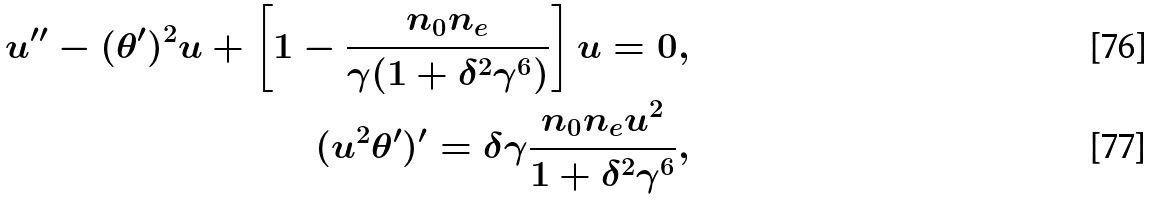Convert formula to latex. <formula><loc_0><loc_0><loc_500><loc_500>u ^ { \prime \prime } - ( \theta ^ { \prime } ) ^ { 2 } u + \left [ 1 - \frac { n _ { 0 } n _ { e } } { \gamma ( 1 + \delta ^ { 2 } \gamma ^ { 6 } ) } \right ] u = 0 , \\ ( u ^ { 2 } \theta ^ { \prime } ) ^ { \prime } = \delta \gamma \frac { n _ { 0 } n _ { e } u ^ { 2 } } { 1 + \delta ^ { 2 } \gamma ^ { 6 } } ,</formula> 